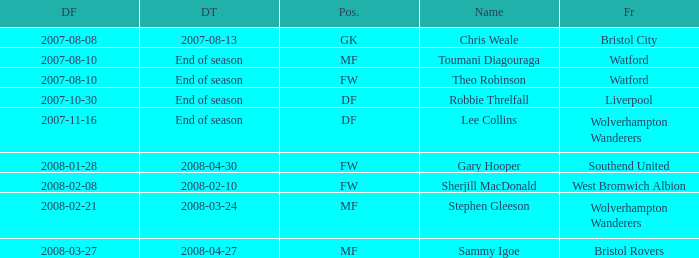What was the name for the row with Date From of 2008-02-21? Stephen Gleeson. 